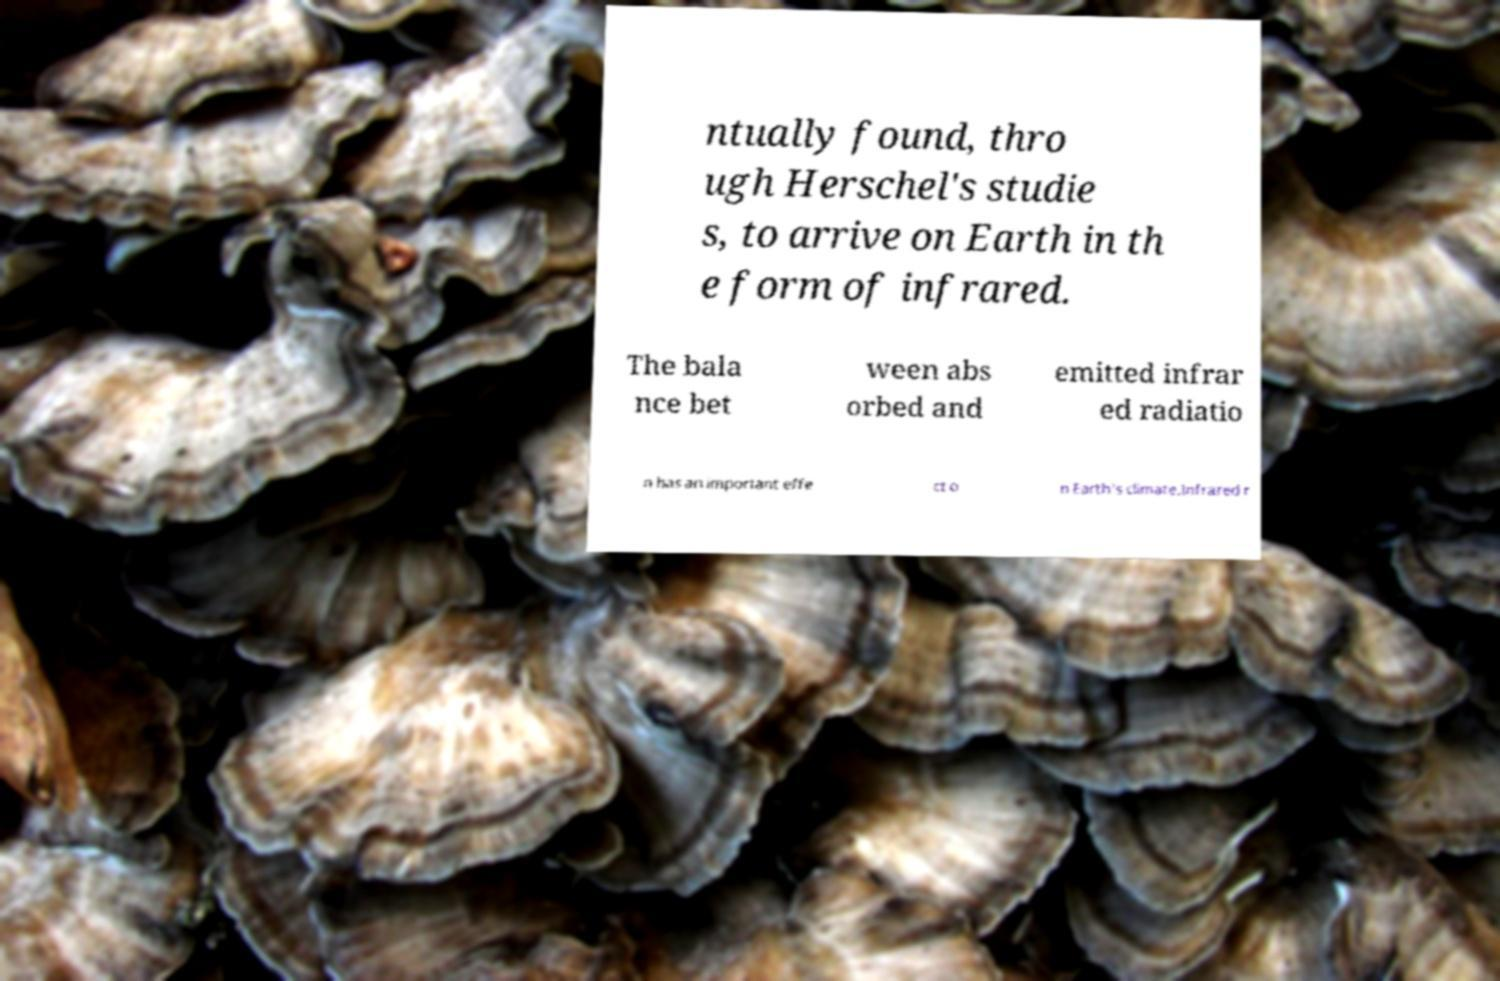Could you assist in decoding the text presented in this image and type it out clearly? ntually found, thro ugh Herschel's studie s, to arrive on Earth in th e form of infrared. The bala nce bet ween abs orbed and emitted infrar ed radiatio n has an important effe ct o n Earth's climate.Infrared r 